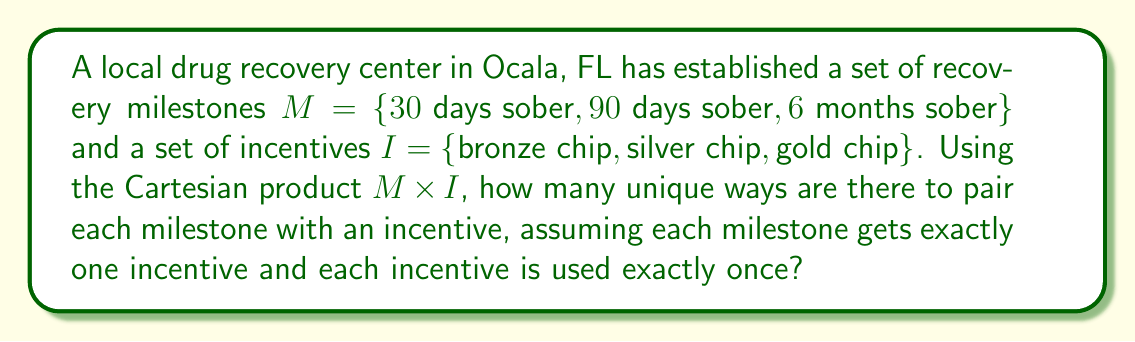What is the answer to this math problem? To solve this problem, we need to understand the Cartesian product and how it relates to pairing elements from two sets.

1) The Cartesian product $M \times I$ gives us all possible pairings of elements from set $M$ with elements from set $I$. This can be represented as:

   $M \times I = \{(m, i) | m \in M, i \in I\}$

2) The number of elements in the Cartesian product is:

   $|M \times I| = |M| \cdot |I| = 3 \cdot 3 = 9$

3) However, the question asks for pairings where each milestone gets exactly one incentive and each incentive is used exactly once. This is equivalent to finding the number of bijective functions from $M$ to $I$.

4) The number of such bijective functions is given by the factorial of the number of elements in either set:

   $3! = 3 \cdot 2 \cdot 1 = 6$

5) This can be understood as follows:
   - For the first milestone, we have 3 choices of incentives
   - For the second milestone, we have 2 remaining choices
   - For the last milestone, we have only 1 choice left

6) Therefore, the total number of ways to pair each milestone with an incentive, under the given conditions, is 6.
Answer: 6 